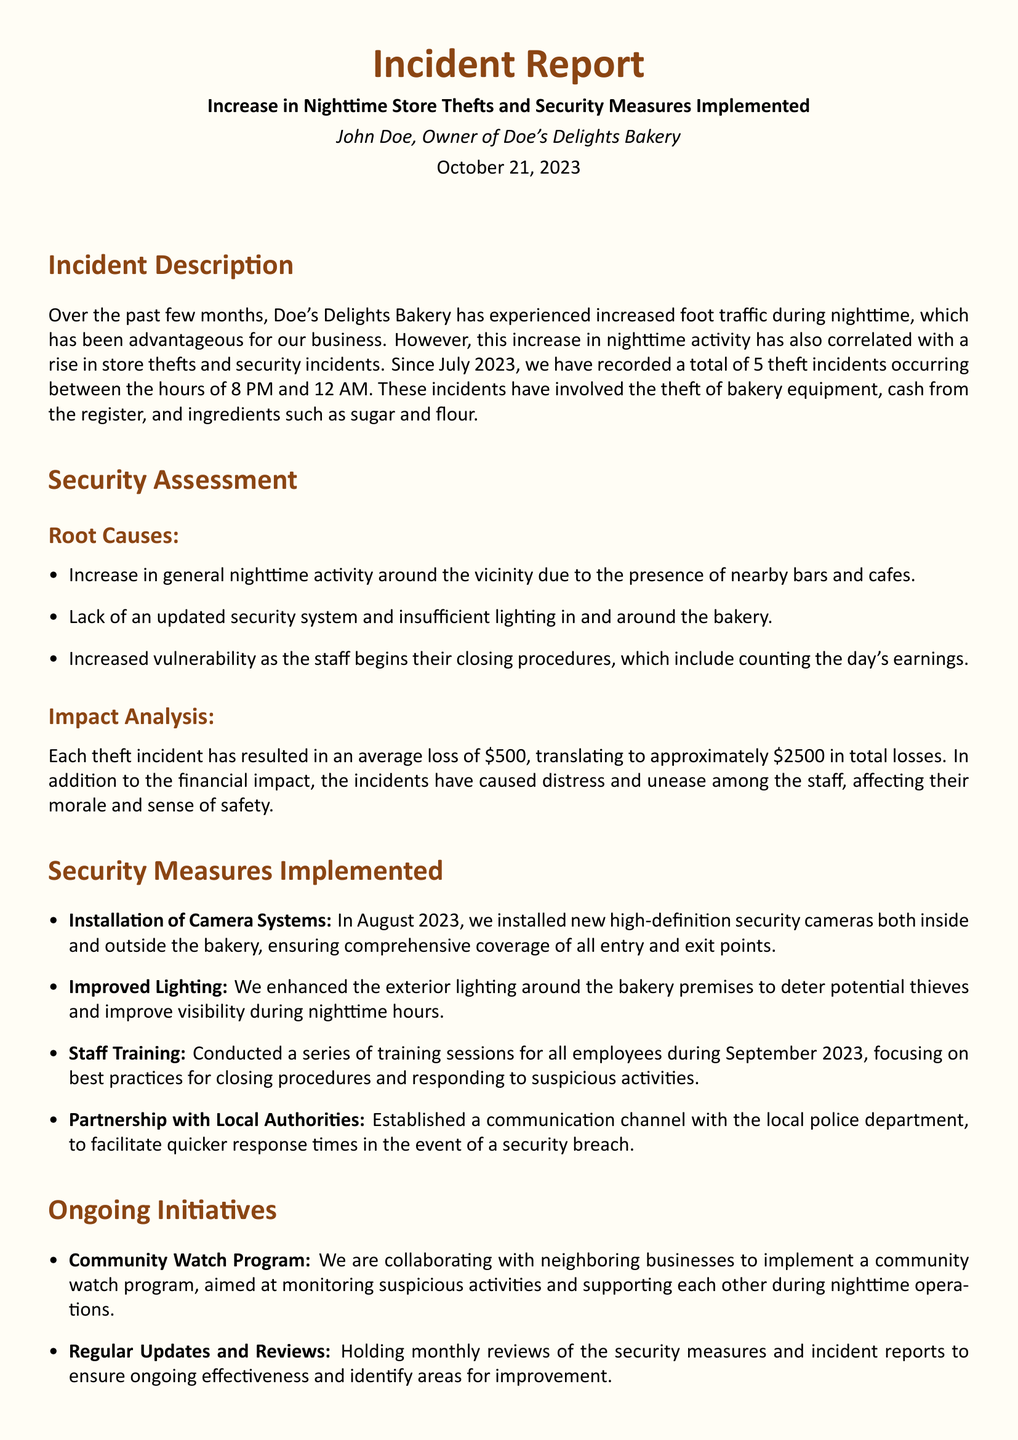what is the total number of theft incidents recorded? The total number of theft incidents recorded since July 2023 is mentioned in the document.
Answer: 5 what is the average loss per theft incident? The average loss from each theft incident is stated in the financial impact section of the report.
Answer: $500 what are the security measures implemented? The document lists specific actions taken for security improvement under the relevant section.
Answer: Installation of Camera Systems, Improved Lighting, Staff Training, Partnership with Local Authorities who authored the incident report? The report specifies the author's name at the beginning of the document.
Answer: John Doe when did the theft incidents start occurring? The report mentions the timeframe during which the theft incidents began.
Answer: July 2023 what is the total financial loss from the theft incidents? The total financial loss is derived from the average loss multiplied by the number of incidents.
Answer: $2500 what initiative is being implemented with neighboring businesses? The document discusses a community initiative aimed at enhancing security.
Answer: Community Watch Program what action was taken in August 2023? The report provides a specific security enhancement that occurred in a particular month.
Answer: Installation of Camera Systems what improvement was made regarding lighting? The report indicates enhancements made to the bakery’s lighting for security reasons.
Answer: Improved Lighting 